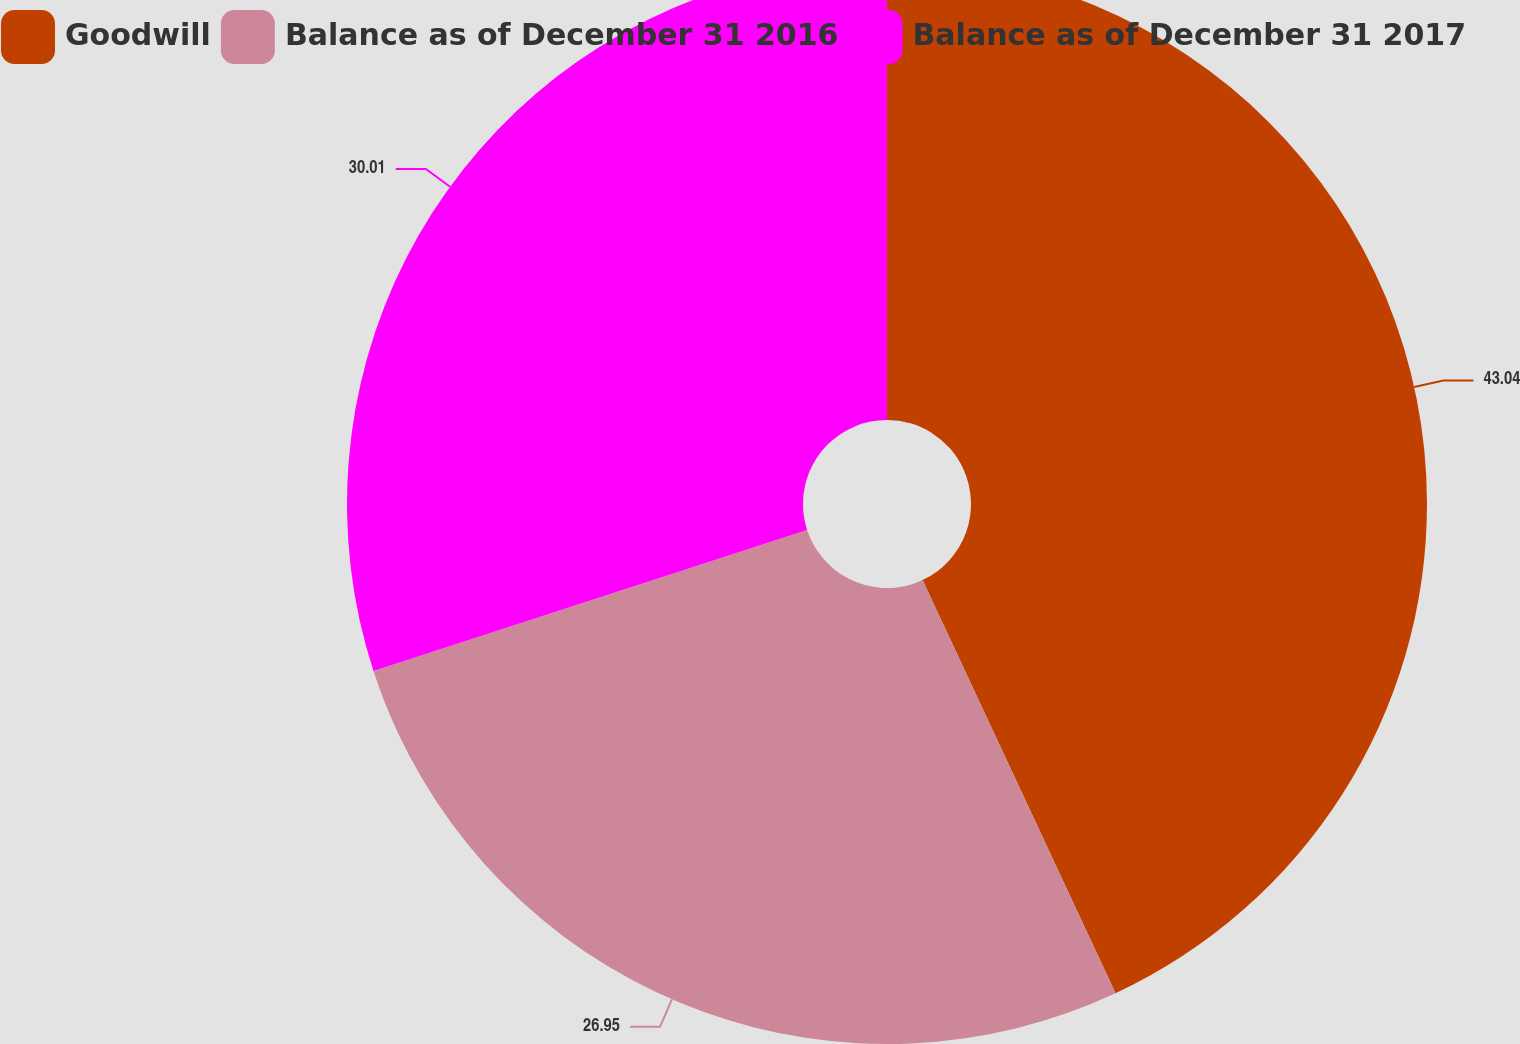<chart> <loc_0><loc_0><loc_500><loc_500><pie_chart><fcel>Goodwill<fcel>Balance as of December 31 2016<fcel>Balance as of December 31 2017<nl><fcel>43.05%<fcel>26.95%<fcel>30.01%<nl></chart> 